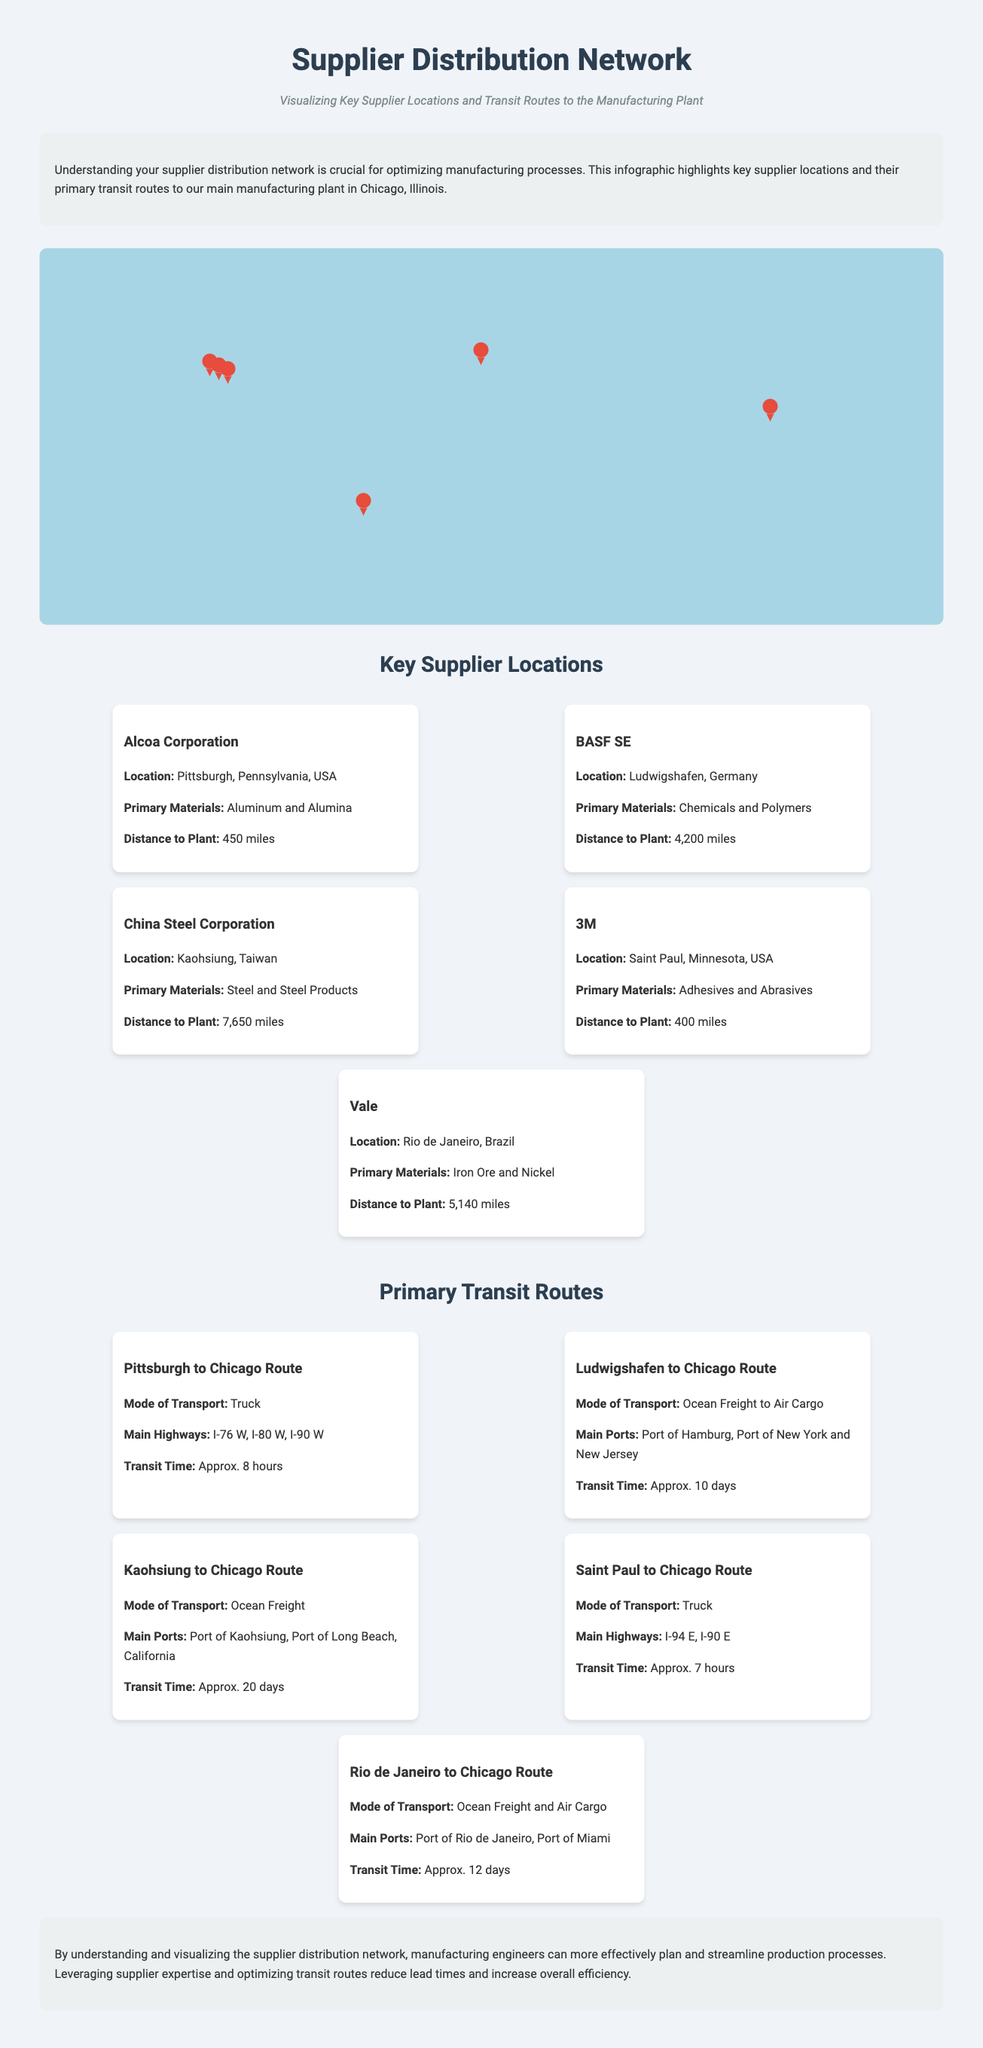what is the primary material supplied by Alcoa Corporation? The document states that Alcoa Corporation supplies Aluminum and Alumina.
Answer: Aluminum and Alumina how far is BASF SE from the manufacturing plant? The document indicates that BASF SE is located 4,200 miles from the manufacturing plant in Chicago.
Answer: 4,200 miles what mode of transport is used for the route from Pittsburgh to Chicago? According to the document, the mode of transport for this route is Truck.
Answer: Truck which supplier is located in Saint Paul, Minnesota? The document identifies 3M as the supplier located in Saint Paul, Minnesota.
Answer: 3M what is the approximate transit time for the route from Kaohsiung to Chicago? The document states that the transit time for this route is approximately 20 days.
Answer: Approx. 20 days which country is the China Steel Corporation located in? The document specifies that China Steel Corporation is located in Taiwan.
Answer: Taiwan what are the main highways for the route from Saint Paul to Chicago? The document lists I-94 E and I-90 E as the main highways for this route.
Answer: I-94 E, I-90 E how many supplier locations are shown on the map? The document shows a total of five supplier locations on the map.
Answer: Five what is the distance from Vale to the manufacturing plant? The distance from Vale to the manufacturing plant is indicated as 5,140 miles in the document.
Answer: 5,140 miles 